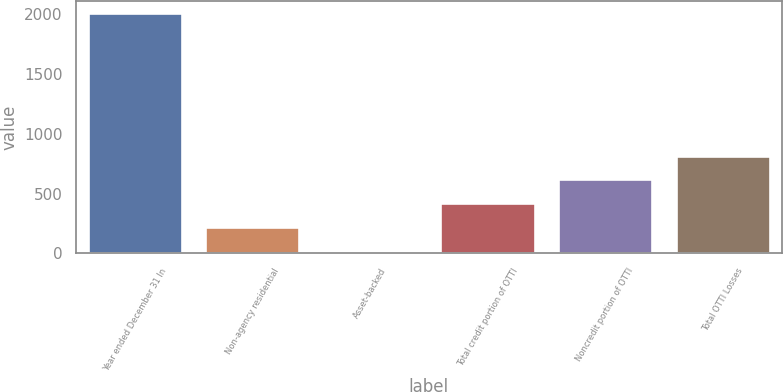Convert chart to OTSL. <chart><loc_0><loc_0><loc_500><loc_500><bar_chart><fcel>Year ended December 31 In<fcel>Non-agency residential<fcel>Asset-backed<fcel>Total credit portion of OTTI<fcel>Noncredit portion of OTTI<fcel>Total OTTI Losses<nl><fcel>2011<fcel>220<fcel>21<fcel>419<fcel>618<fcel>817<nl></chart> 